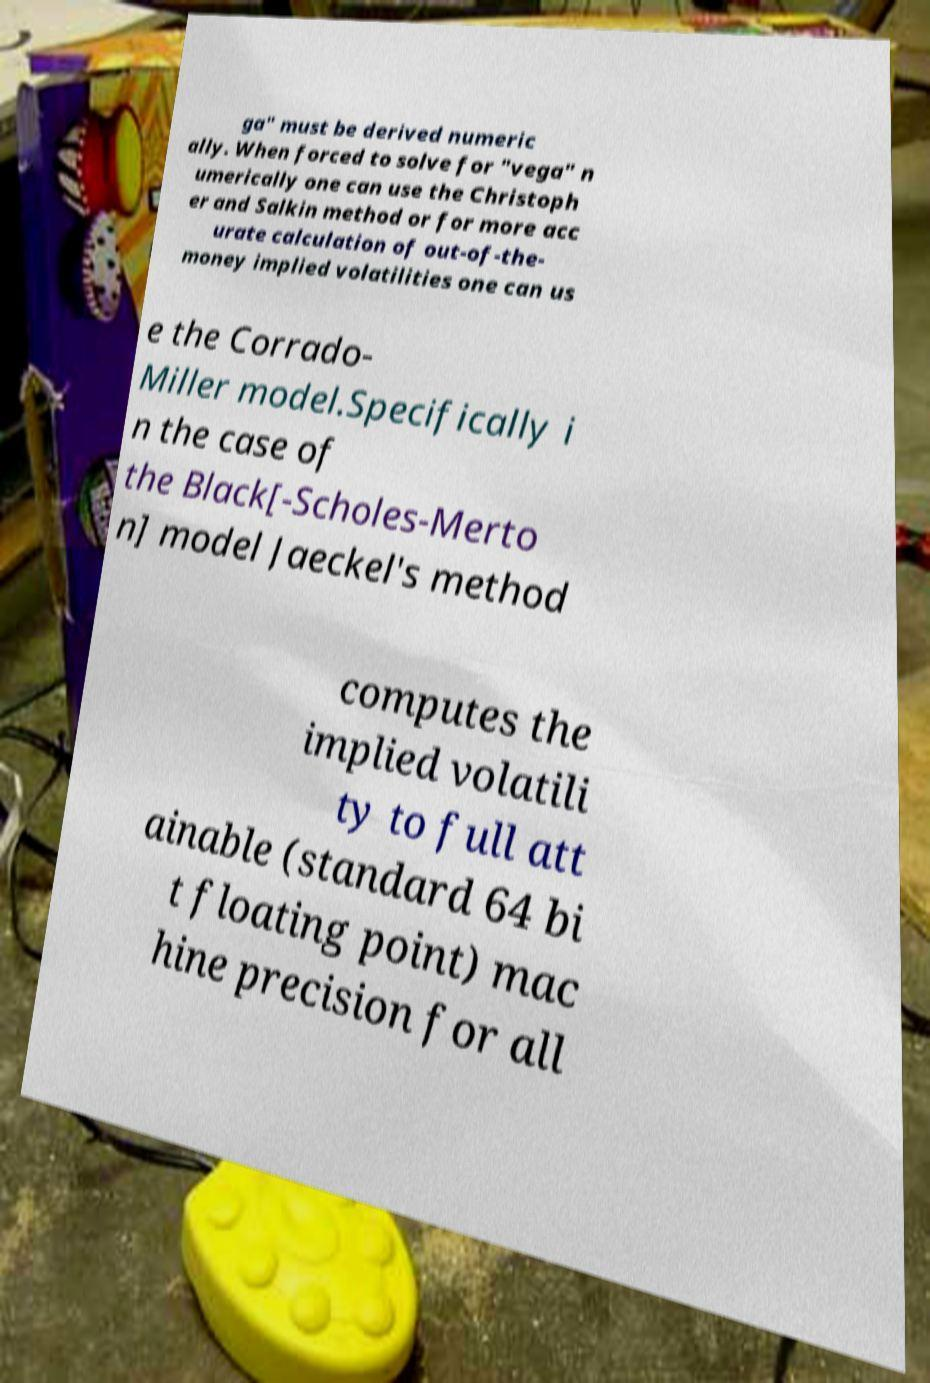Please identify and transcribe the text found in this image. ga" must be derived numeric ally. When forced to solve for "vega" n umerically one can use the Christoph er and Salkin method or for more acc urate calculation of out-of-the- money implied volatilities one can us e the Corrado- Miller model.Specifically i n the case of the Black[-Scholes-Merto n] model Jaeckel's method computes the implied volatili ty to full att ainable (standard 64 bi t floating point) mac hine precision for all 